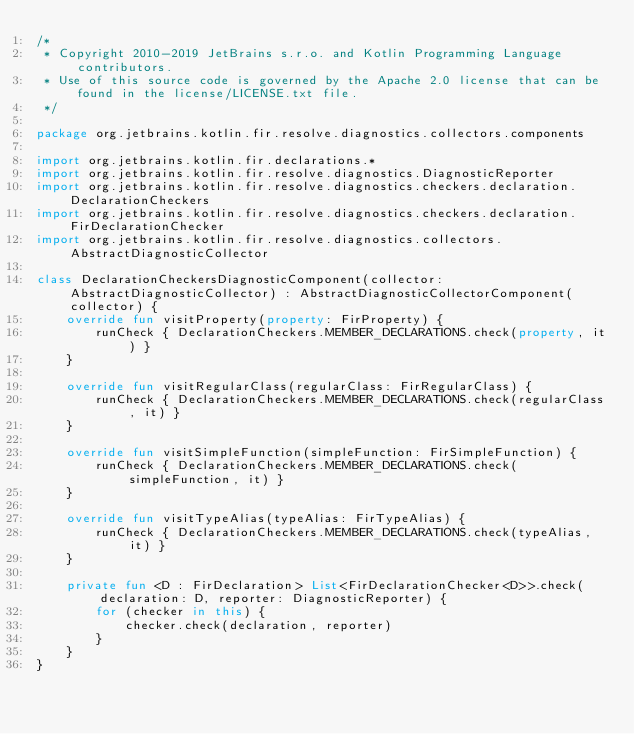Convert code to text. <code><loc_0><loc_0><loc_500><loc_500><_Kotlin_>/*
 * Copyright 2010-2019 JetBrains s.r.o. and Kotlin Programming Language contributors.
 * Use of this source code is governed by the Apache 2.0 license that can be found in the license/LICENSE.txt file.
 */

package org.jetbrains.kotlin.fir.resolve.diagnostics.collectors.components

import org.jetbrains.kotlin.fir.declarations.*
import org.jetbrains.kotlin.fir.resolve.diagnostics.DiagnosticReporter
import org.jetbrains.kotlin.fir.resolve.diagnostics.checkers.declaration.DeclarationCheckers
import org.jetbrains.kotlin.fir.resolve.diagnostics.checkers.declaration.FirDeclarationChecker
import org.jetbrains.kotlin.fir.resolve.diagnostics.collectors.AbstractDiagnosticCollector

class DeclarationCheckersDiagnosticComponent(collector: AbstractDiagnosticCollector) : AbstractDiagnosticCollectorComponent(collector) {
    override fun visitProperty(property: FirProperty) {
        runCheck { DeclarationCheckers.MEMBER_DECLARATIONS.check(property, it) }
    }

    override fun visitRegularClass(regularClass: FirRegularClass) {
        runCheck { DeclarationCheckers.MEMBER_DECLARATIONS.check(regularClass, it) }
    }

    override fun visitSimpleFunction(simpleFunction: FirSimpleFunction) {
        runCheck { DeclarationCheckers.MEMBER_DECLARATIONS.check(simpleFunction, it) }
    }

    override fun visitTypeAlias(typeAlias: FirTypeAlias) {
        runCheck { DeclarationCheckers.MEMBER_DECLARATIONS.check(typeAlias, it) }
    }

    private fun <D : FirDeclaration> List<FirDeclarationChecker<D>>.check(declaration: D, reporter: DiagnosticReporter) {
        for (checker in this) {
            checker.check(declaration, reporter)
        }
    }
}</code> 